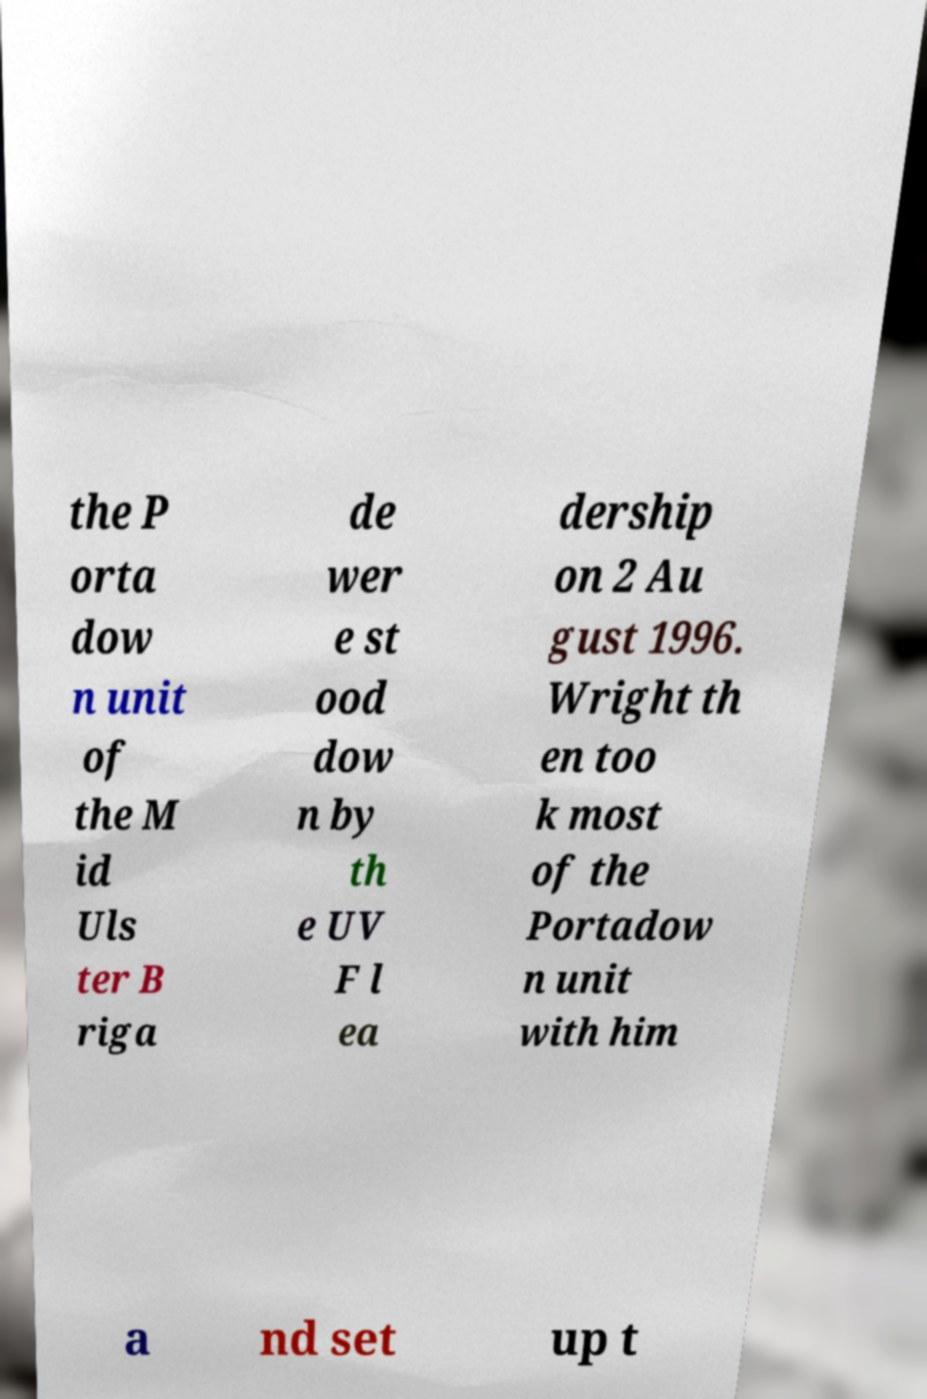There's text embedded in this image that I need extracted. Can you transcribe it verbatim? the P orta dow n unit of the M id Uls ter B riga de wer e st ood dow n by th e UV F l ea dership on 2 Au gust 1996. Wright th en too k most of the Portadow n unit with him a nd set up t 